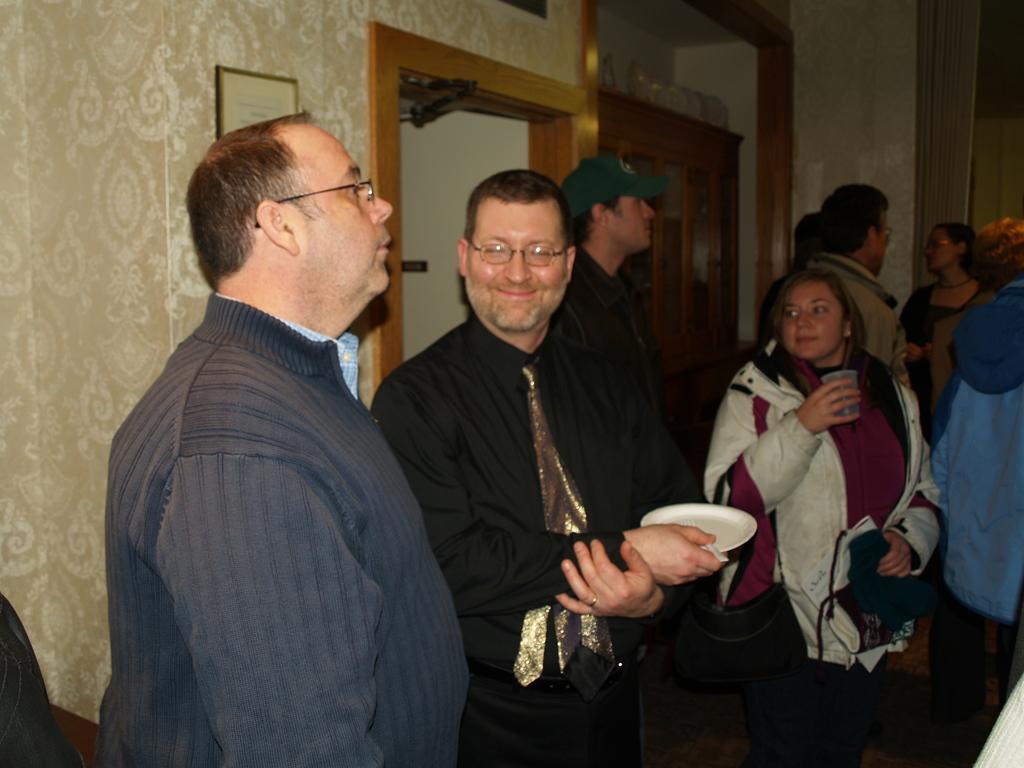Can you describe this image briefly? In the image there are few people standing. Few of them are holding plates and glasses. Behind them there is a frame, door and cupboard and also there is a wall. 